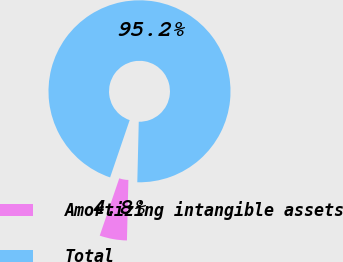<chart> <loc_0><loc_0><loc_500><loc_500><pie_chart><fcel>Amortizing intangible assets<fcel>Total<nl><fcel>4.85%<fcel>95.15%<nl></chart> 